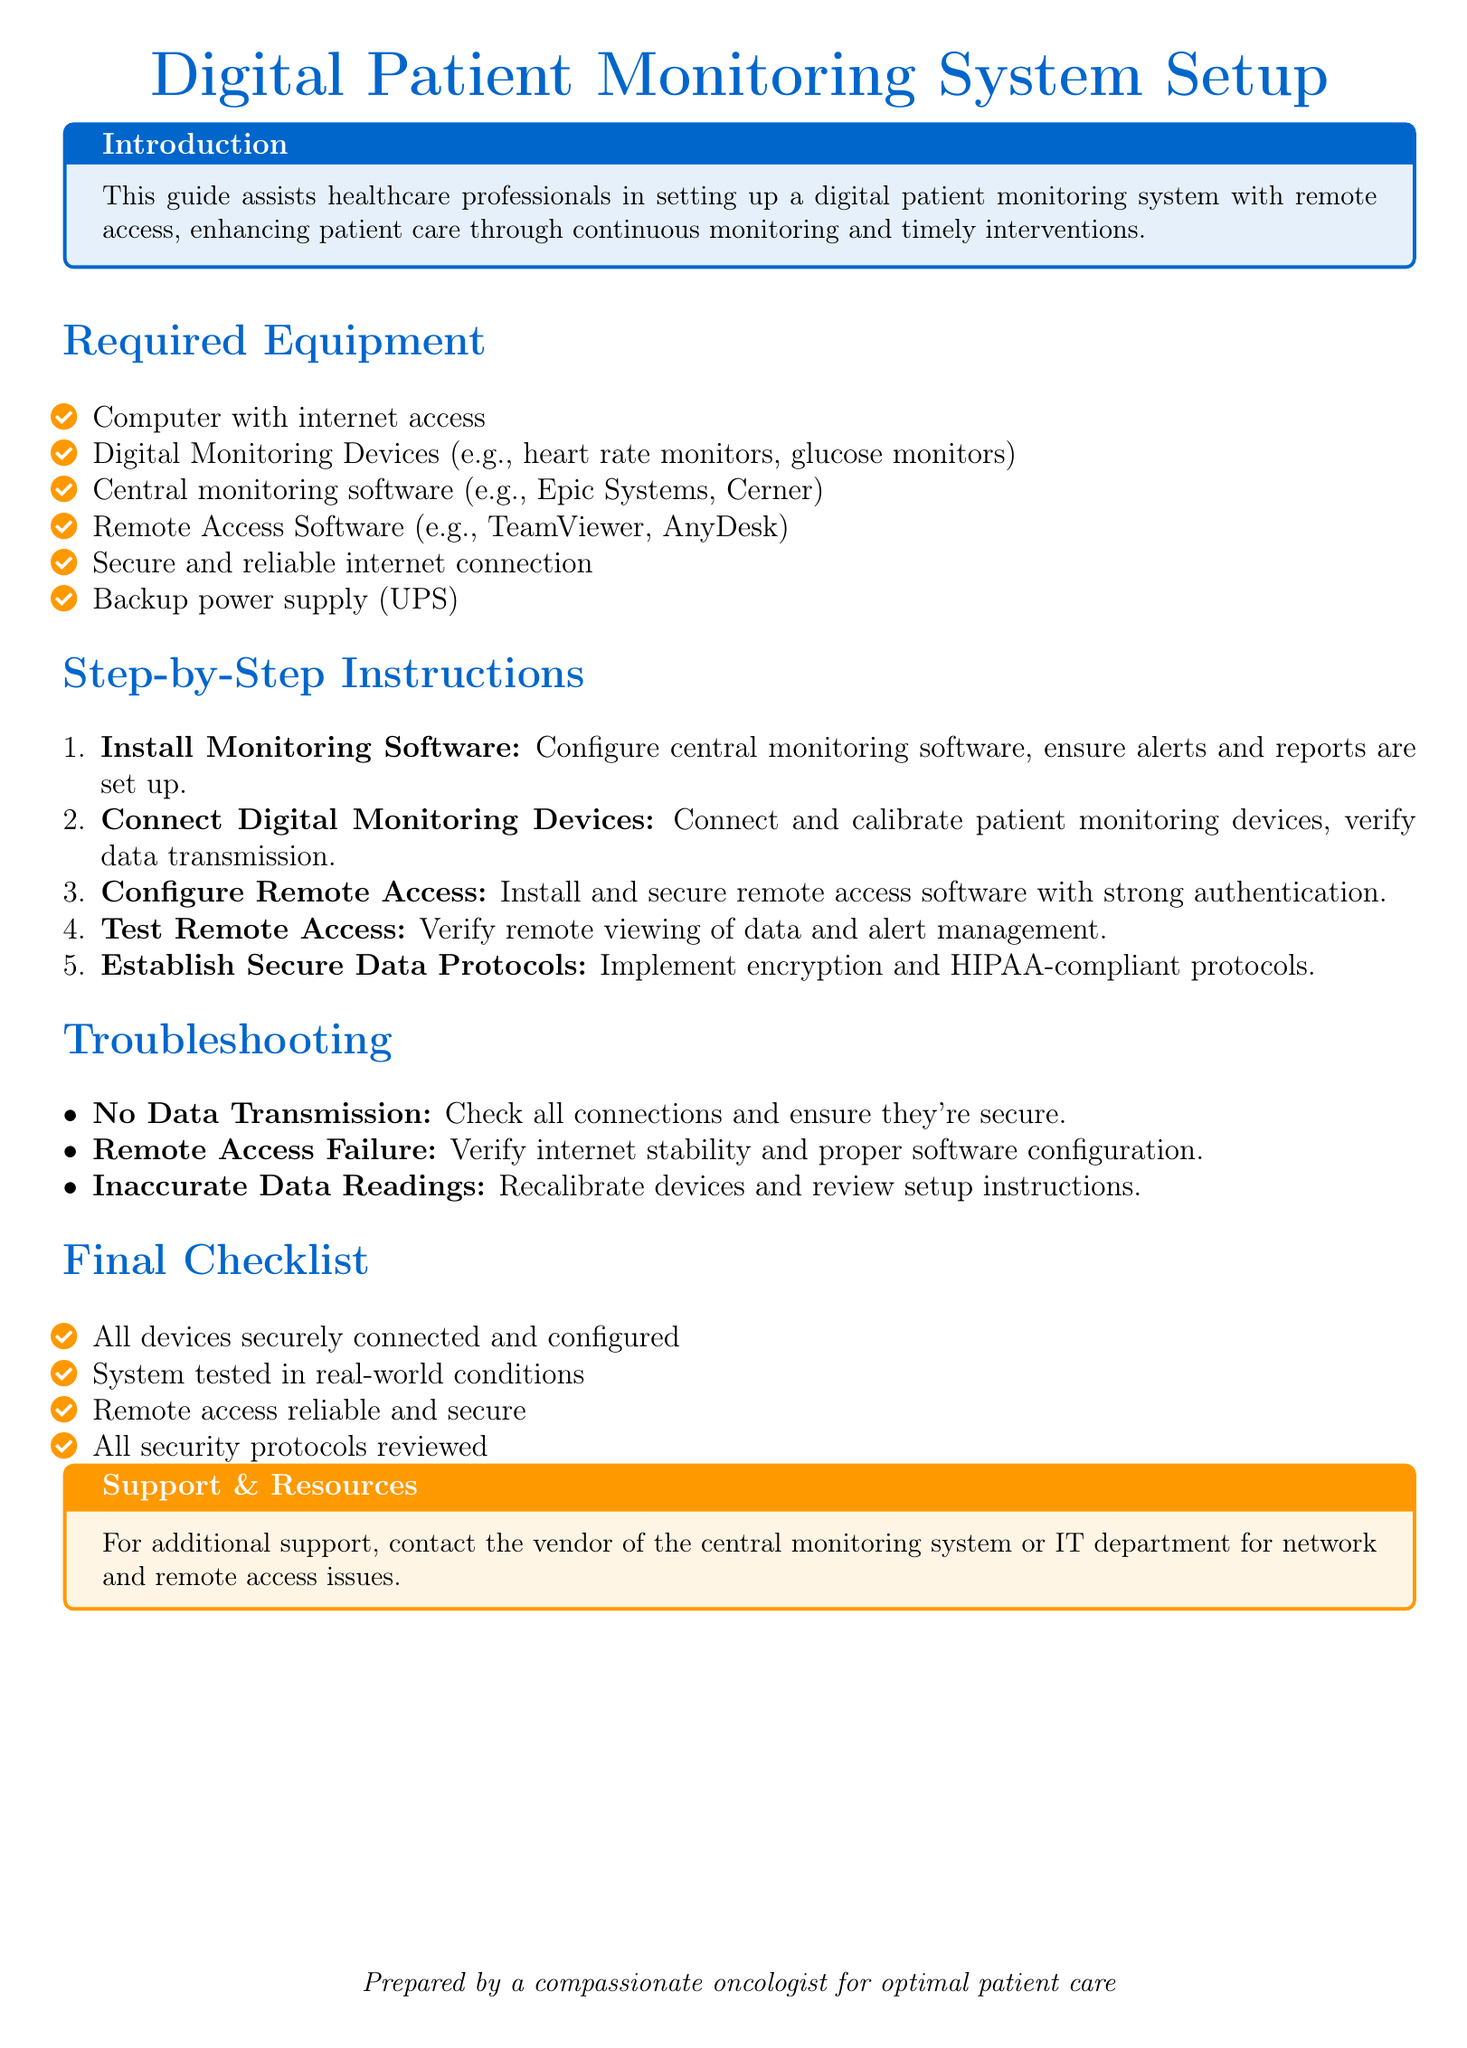What is the title of the document? The title is stated at the top of the document.
Answer: Digital Patient Monitoring System Setup What color is used for the main section titles? The color specification is described in the document format.
Answer: Main color How many required equipment items are listed? The total number of items mentioned under required equipment can be counted.
Answer: Six What is the first step in the setup instructions? The order of steps for setup is outlined in the document.
Answer: Install Monitoring Software What type of equipment is needed for remote access? The equipment needed for remote access is listed in the required equipment section.
Answer: Remote Access Software What should you check if there is no data transmission? The troubleshooting section provides guidance on issues that may arise.
Answer: Check all connections How many troubleshooting points are mentioned? The number of items listed in the troubleshooting section can be counted.
Answer: Three What is the main purpose of this guide? The purpose is stated in the introduction box of the document.
Answer: Assists healthcare professionals What is emphasized for security in data protocols? The final checklist highlights important security aspects.
Answer: Encryption and HIPAA-compliant protocols 